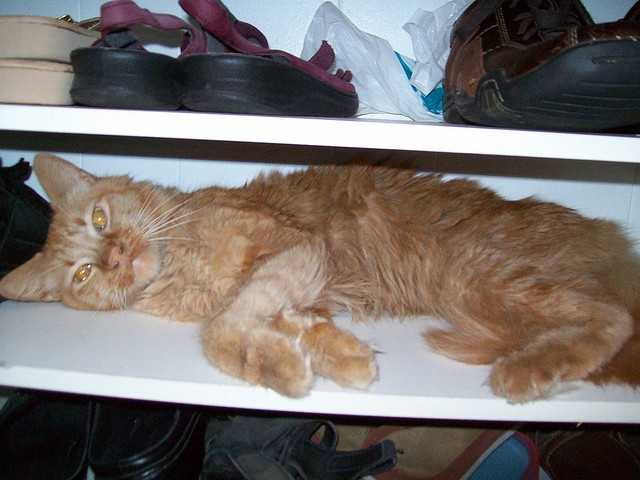Describe the objects in this image and their specific colors. I can see a cat in gray, maroon, tan, and darkgray tones in this image. 